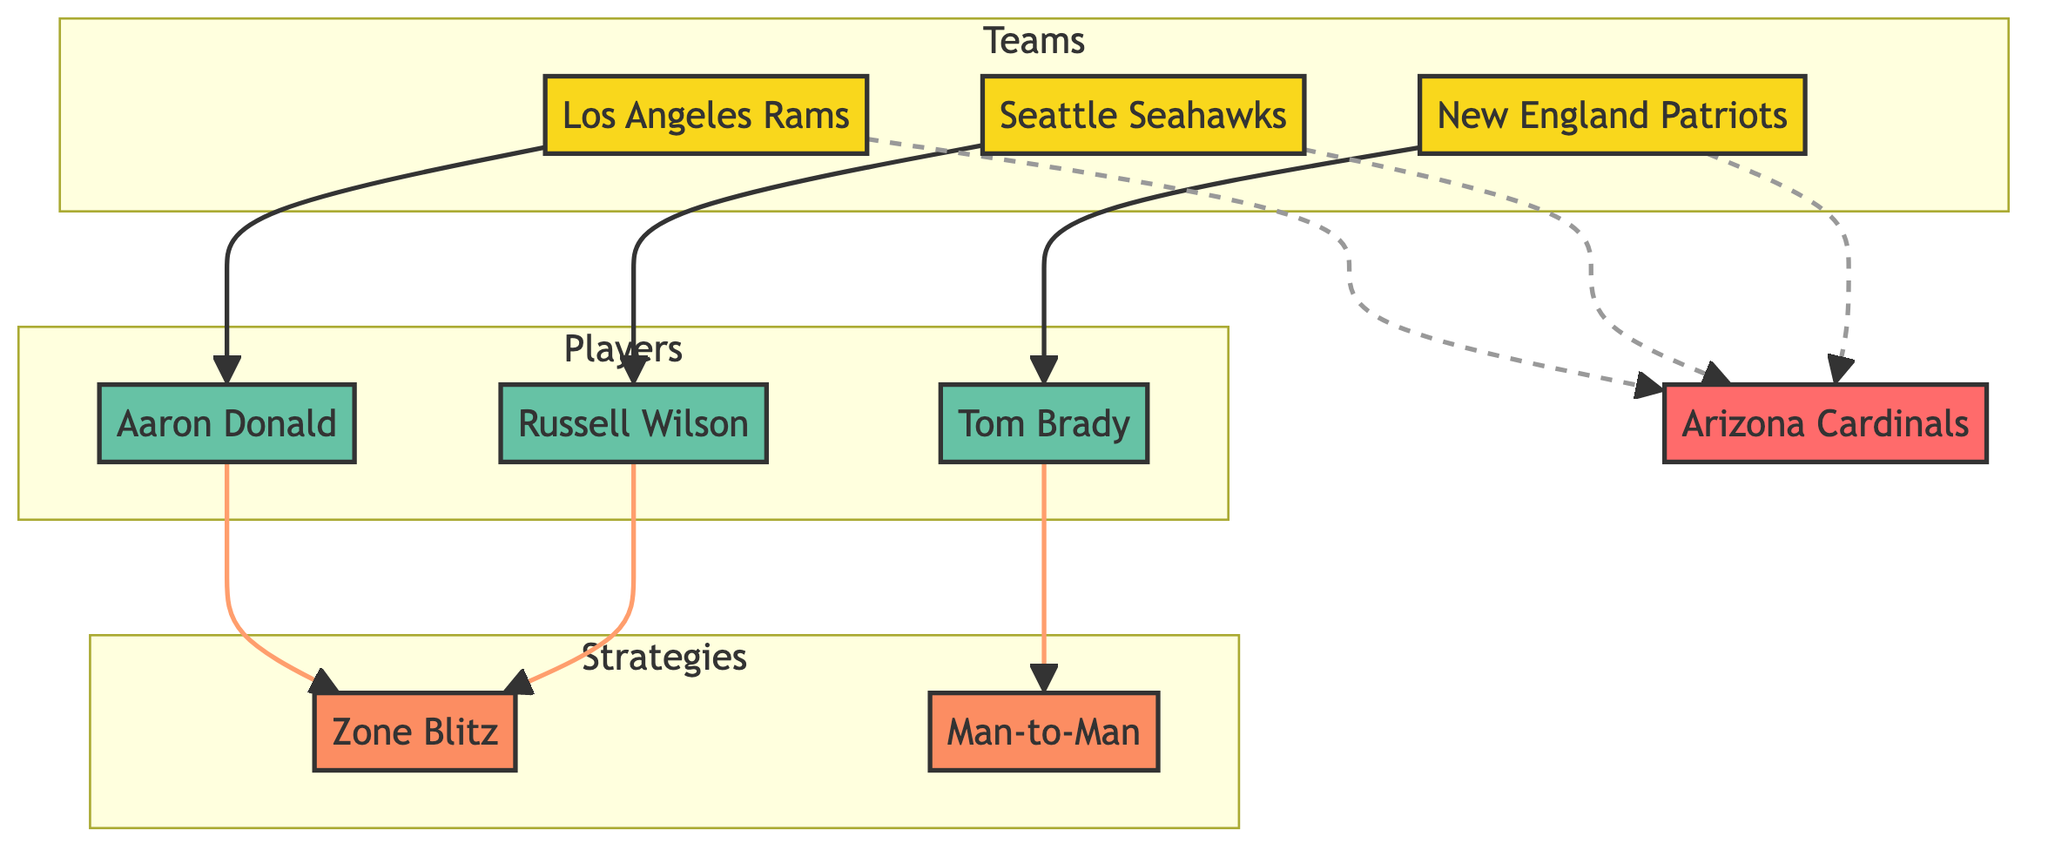What team is associated with Tom Brady? In the diagram, the connection between the New England Patriots and Tom Brady indicates that he is a key player of that team. Thus, New England Patriots is the team associated with Tom Brady.
Answer: New England Patriots How many strategies are shown in the diagram? The diagram includes three distinct strategies: Zone Blitz and Man-to-Man. Counting these, there are a total of two strategies displayed in the diagram.
Answer: 2 Which strategy does Russell Wilson prefer? The directed edge leading from Russell Wilson indicates a preference for a specific strategy, which is labeled as Zone Blitz in the diagram.
Answer: Zone Blitz Which player is linked to the strategy Man-to-Man? The edge pointing from Tom Brady towards the strategy indicates that he prefers Man-to-Man, thus establishing the connection.
Answer: Tom Brady What is the relationship between the Seattle Seahawks and the Arizona Cardinals? The dashed edge labeled "Matchup" indicates a competitive relationship between the Seattle Seahawks and the Arizona Cardinals, showing they have faced each other.
Answer: Matchup Which two players prefer Zone Blitz? Analyzing the edges leading to the Zone Blitz strategy, we see that both Russell Wilson and Aaron Donald have edges pointing to this strategy, indicating their preference for it.
Answer: Russell Wilson, Aaron Donald How many teams are compared to the Arizona Cardinals in this diagram? The lines representing Matchups indicate three different teams compared against the Arizona Cardinals: New England Patriots, Seattle Seahawks, and Los Angeles Rams. Counting these, there are three teams depicted.
Answer: 3 What type of node is Aaron Donald? The diagram classifies Aaron Donald as a player through the formatting and labeling of his node, validating his designation within the network.
Answer: Player 